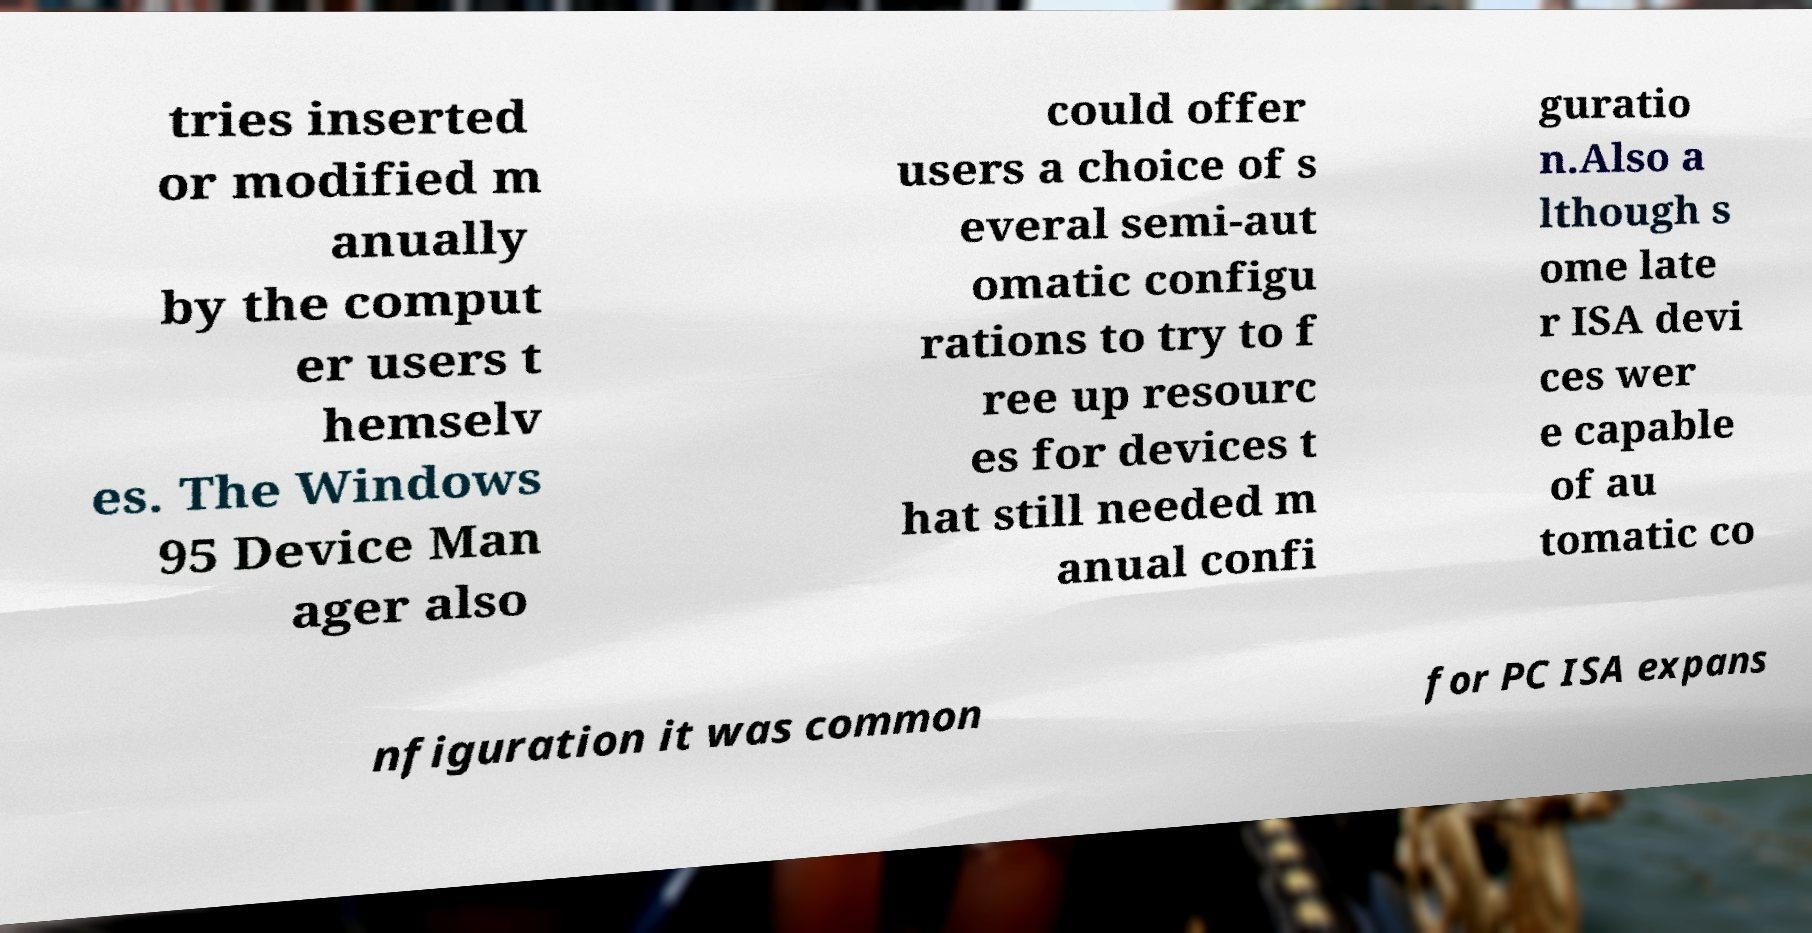Can you accurately transcribe the text from the provided image for me? tries inserted or modified m anually by the comput er users t hemselv es. The Windows 95 Device Man ager also could offer users a choice of s everal semi-aut omatic configu rations to try to f ree up resourc es for devices t hat still needed m anual confi guratio n.Also a lthough s ome late r ISA devi ces wer e capable of au tomatic co nfiguration it was common for PC ISA expans 